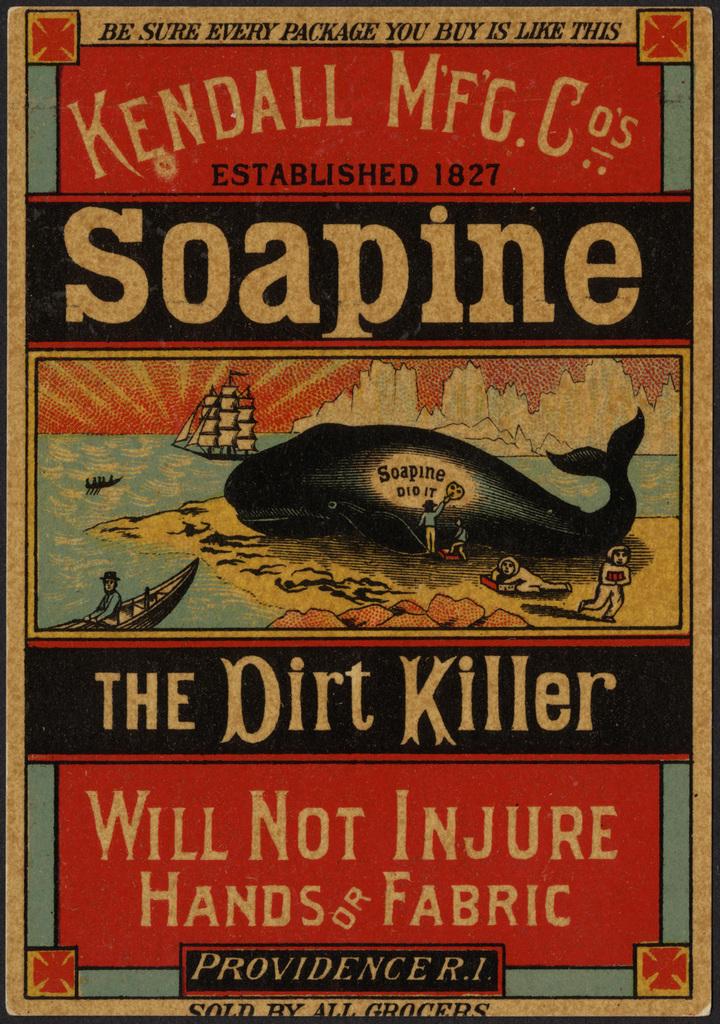The what killer?
Give a very brief answer. Dirt. 